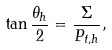Convert formula to latex. <formula><loc_0><loc_0><loc_500><loc_500>\tan \frac { \theta _ { h } } { 2 } = \frac { \Sigma } { P _ { t , h } } ,</formula> 